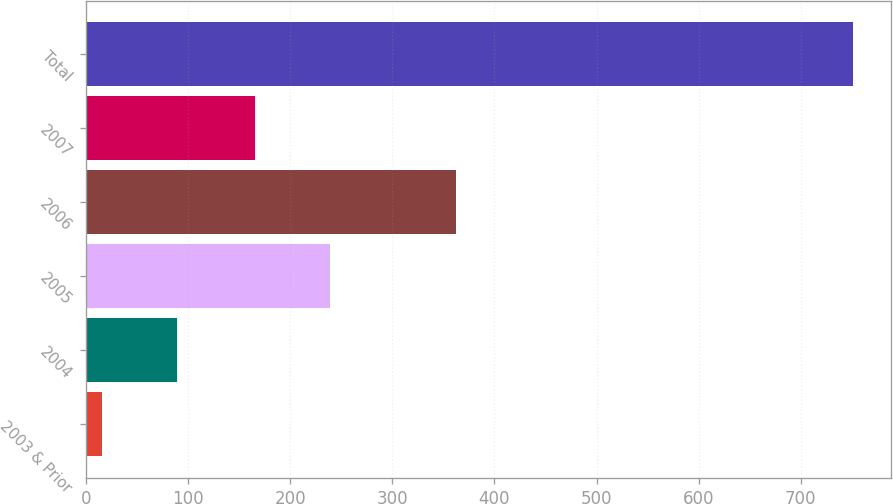<chart> <loc_0><loc_0><loc_500><loc_500><bar_chart><fcel>2003 & Prior<fcel>2004<fcel>2005<fcel>2006<fcel>2007<fcel>Total<nl><fcel>16<fcel>89.5<fcel>239.5<fcel>362<fcel>166<fcel>751<nl></chart> 